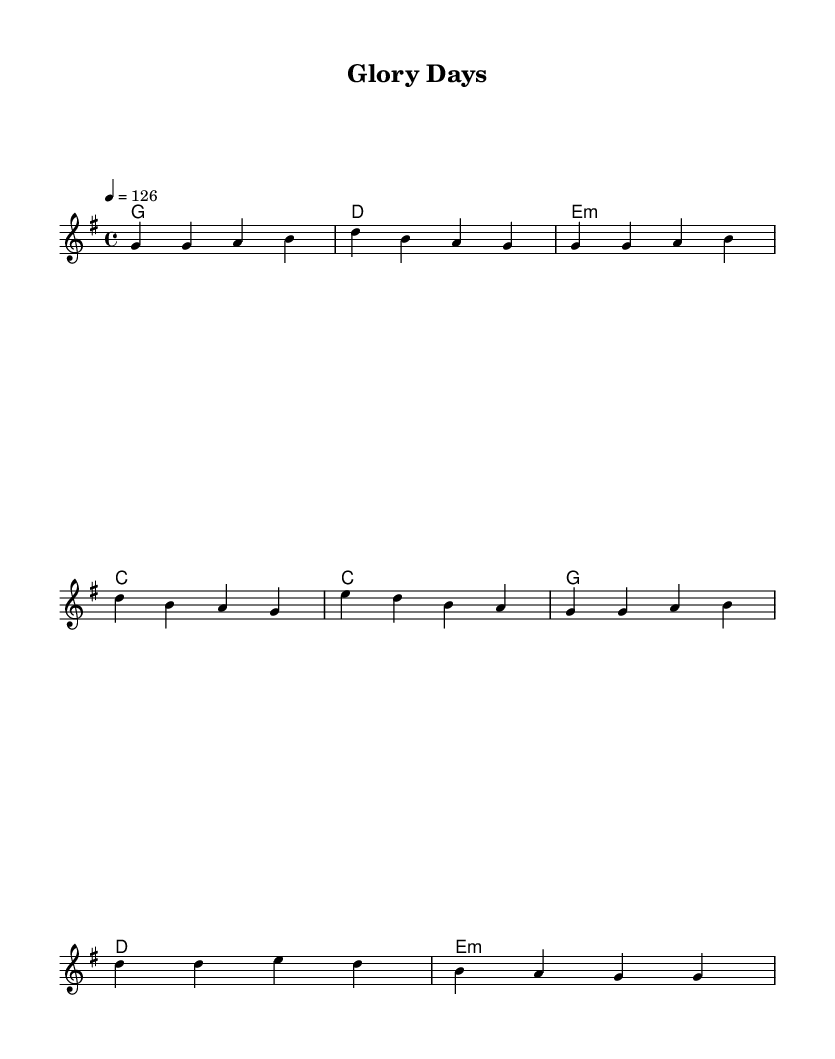What is the key signature of this music? The key signature appears at the beginning of the staff, showing one sharp. This indicates that the key is G major.
Answer: G major What is the time signature of this music? The time signature is indicated at the beginning of the score, where the symbol shows a 4 above a 4. This means there are four beats in each measure and the quarter note gets one beat.
Answer: 4/4 What is the tempo of the piece? The tempo is stated in the score, denoted by the number "126" with a quarter note symbol "4 = 126." This indicates that the piece should be played at 126 beats per minute.
Answer: 126 What chords are used in the verse section? Looking at the harmony section, the chords listed for the verse are G, D, E minor, and C. These can be seen aligned with the melody's corresponding measures.
Answer: G, D, E minor, C In which section is the lyric "Glory days, they're not so far"? This lyric is part of the chorus. It follows the verse lyrics and is written below the melody, indicating it is sung during that section of the music.
Answer: Chorus How many measures are there in the chorus? If we count the measures in the chorus section indicated by the harmonies, there are four measures (C, G, D, E minor), confirming that the chorus consists of four distinct measures.
Answer: 4 What musical genre does this piece represent? The piece has attributes such as melodic structure and lyrical content which align with characteristics typical of rock music, especially from the early 2000s, indicating that it falls under the rock genre.
Answer: Rock 